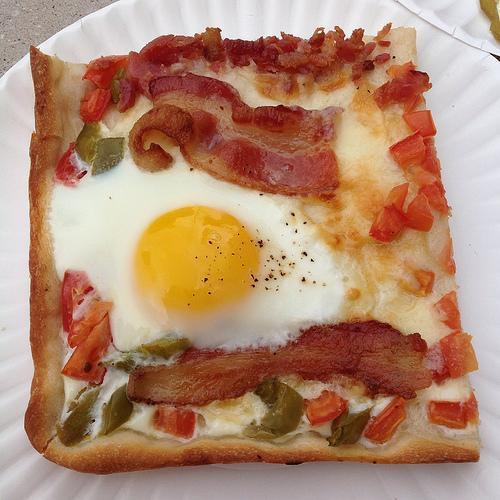How many slices of bacon are there?
Give a very brief answer. 3. How many slices of pizza are there?
Give a very brief answer. 1. 